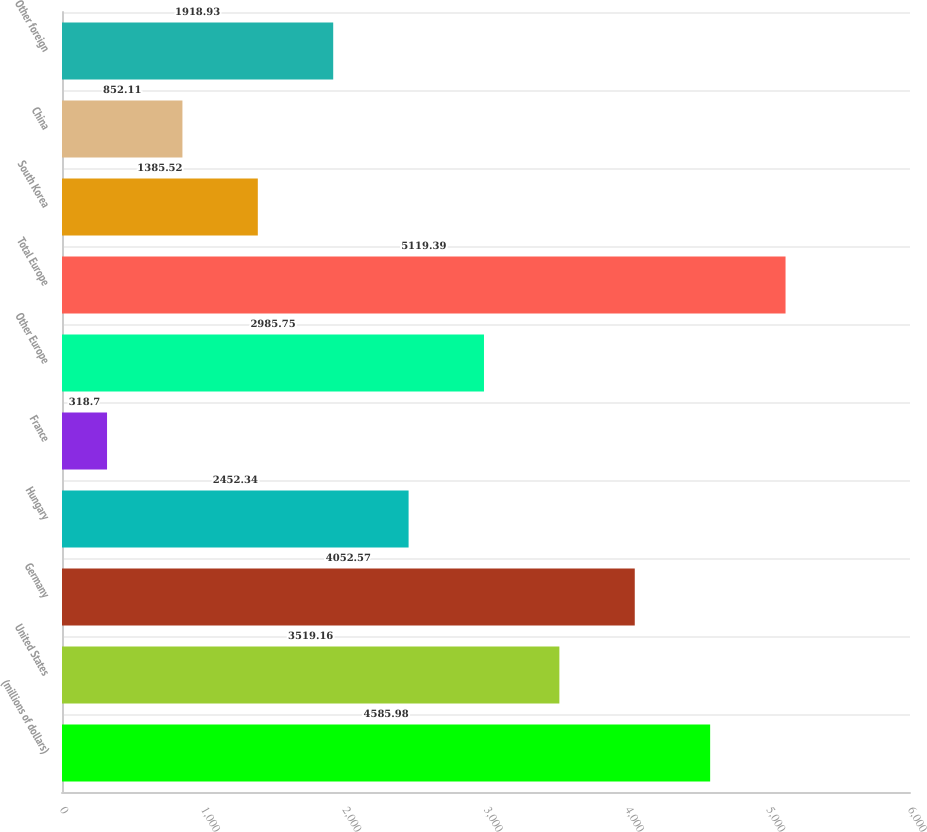Convert chart. <chart><loc_0><loc_0><loc_500><loc_500><bar_chart><fcel>(millions of dollars)<fcel>United States<fcel>Germany<fcel>Hungary<fcel>France<fcel>Other Europe<fcel>Total Europe<fcel>South Korea<fcel>China<fcel>Other foreign<nl><fcel>4585.98<fcel>3519.16<fcel>4052.57<fcel>2452.34<fcel>318.7<fcel>2985.75<fcel>5119.39<fcel>1385.52<fcel>852.11<fcel>1918.93<nl></chart> 